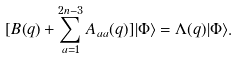Convert formula to latex. <formula><loc_0><loc_0><loc_500><loc_500>[ B ( q ) + \sum _ { a = 1 } ^ { 2 n - 3 } A _ { a a } ( q ) ] | \Phi \rangle = \Lambda ( q ) | \Phi \rangle .</formula> 